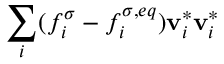Convert formula to latex. <formula><loc_0><loc_0><loc_500><loc_500>\sum _ { i } ( f _ { i } ^ { \sigma } - f _ { i } ^ { \sigma , e q } ) v _ { i } ^ { * } v _ { i } ^ { * }</formula> 